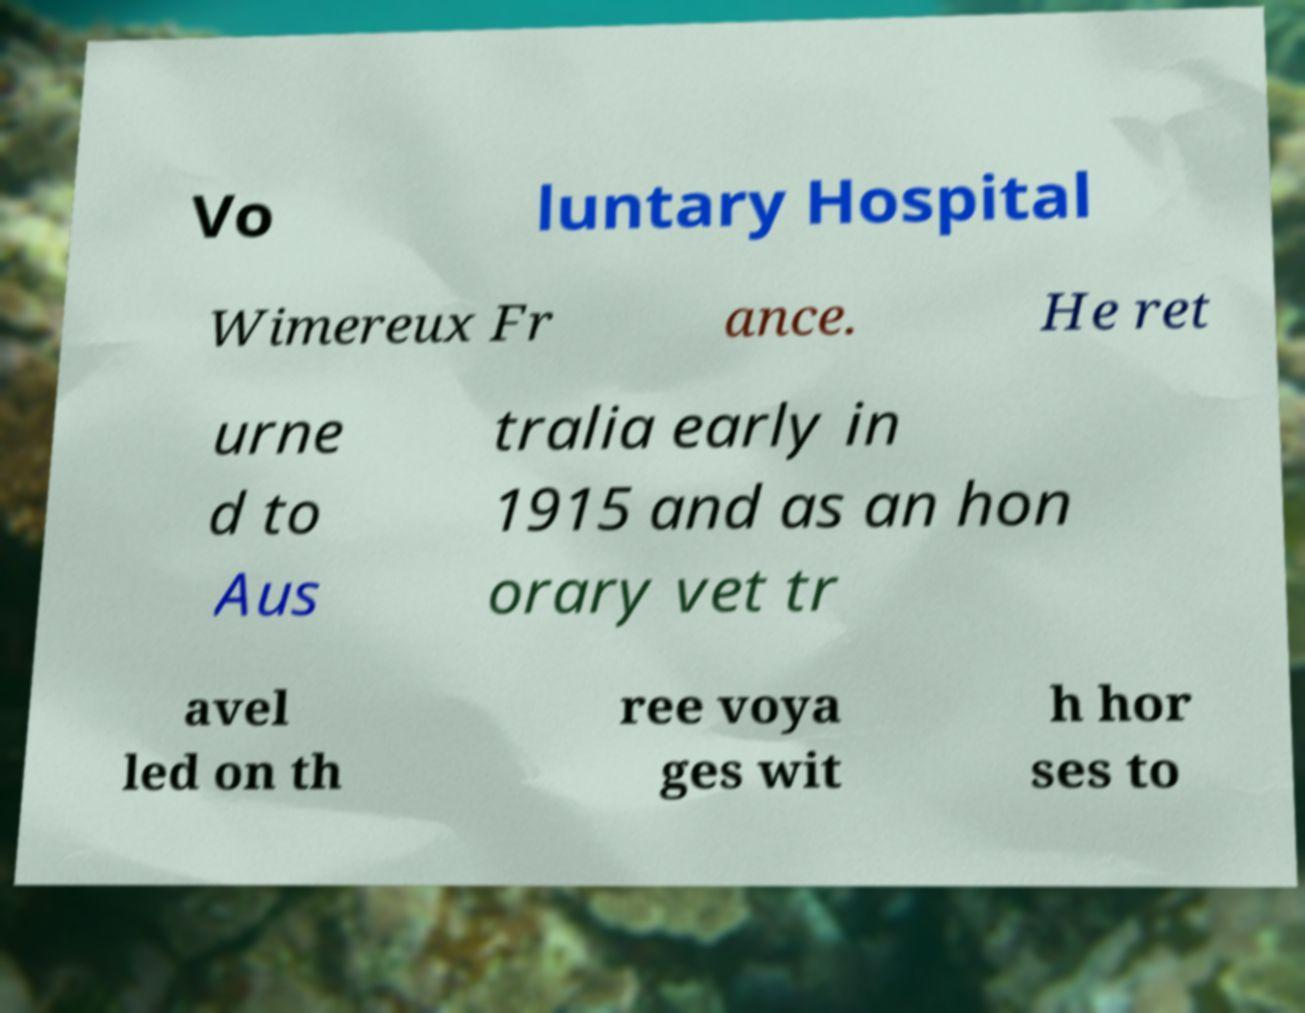Can you accurately transcribe the text from the provided image for me? Vo luntary Hospital Wimereux Fr ance. He ret urne d to Aus tralia early in 1915 and as an hon orary vet tr avel led on th ree voya ges wit h hor ses to 